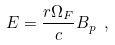Convert formula to latex. <formula><loc_0><loc_0><loc_500><loc_500>E = \frac { r \Omega _ { F } } { c } B _ { p } \ ,</formula> 